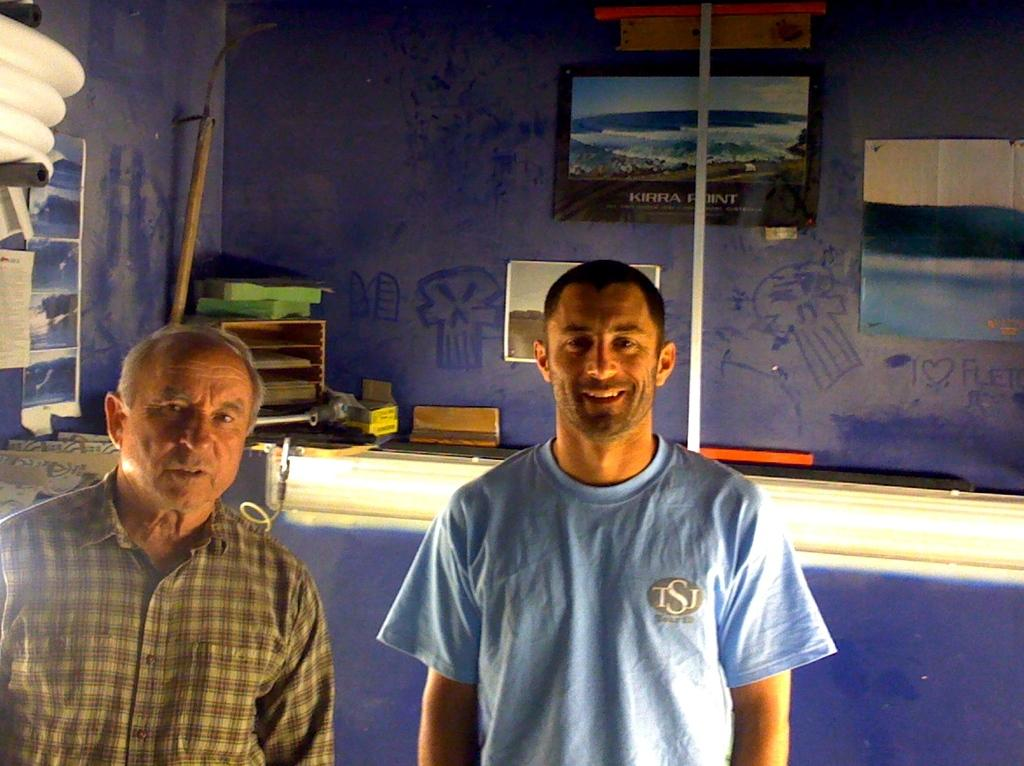What is the color of the wall in the image? There is a blue color wall in the image. What can be seen hanging on the wall in the image? There are photo frames in the image. How many people are standing in the front of the image? There are two people standing in the front of the image. What is the woman in the image wearing? The woman in the image is wearing a blue color t-shirt. What type of lumber is being used to build the territory in the image? There is no mention of lumber or territory in the image; it features a blue color wall, photo frames, and two people standing in the front. 